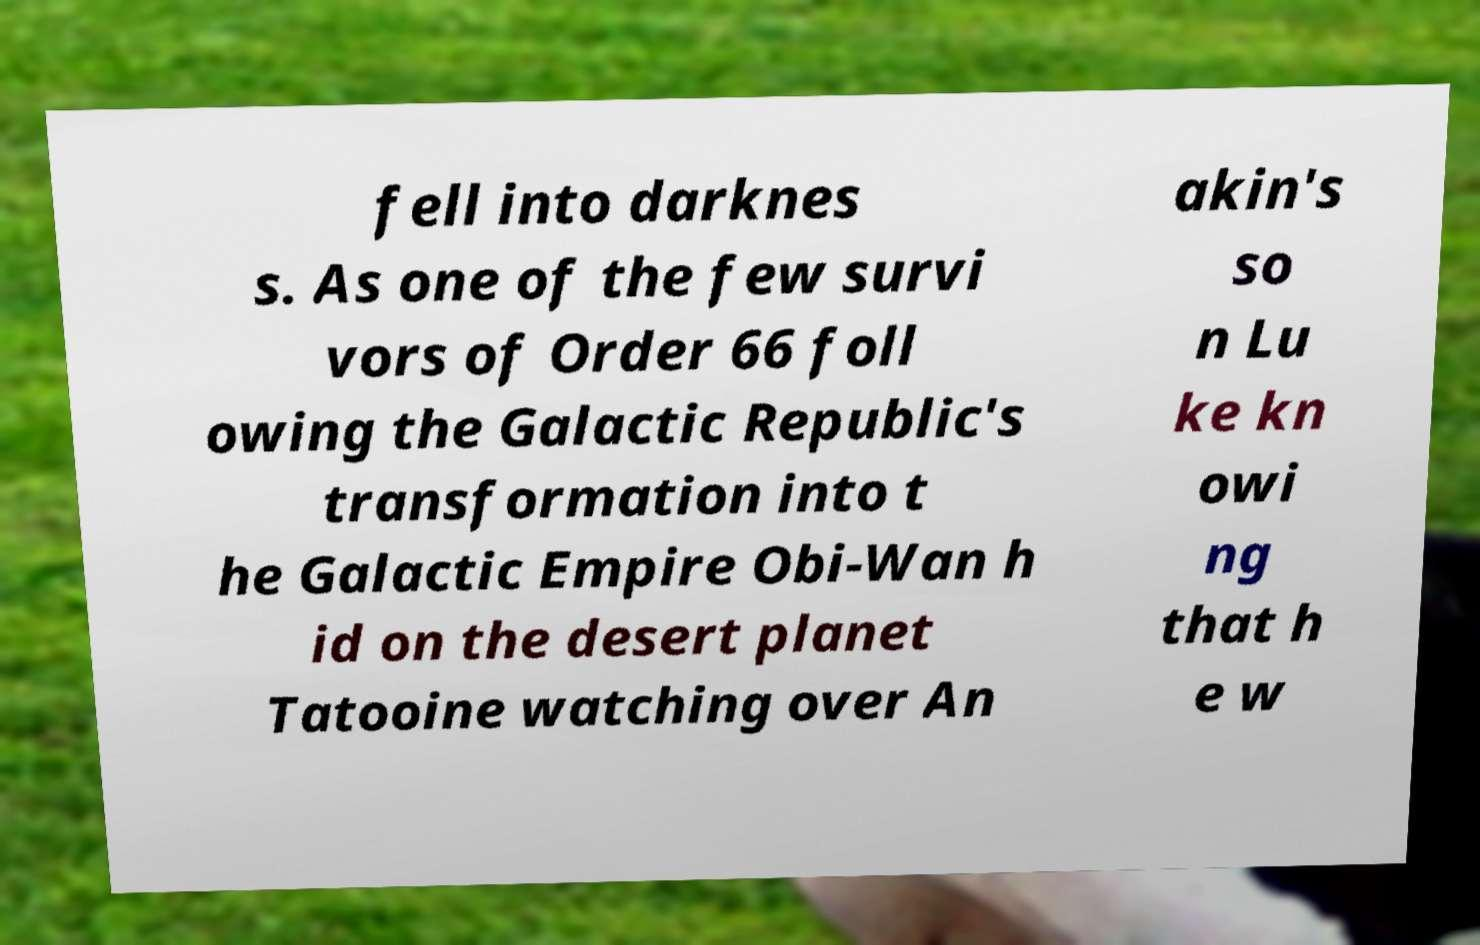Could you assist in decoding the text presented in this image and type it out clearly? fell into darknes s. As one of the few survi vors of Order 66 foll owing the Galactic Republic's transformation into t he Galactic Empire Obi-Wan h id on the desert planet Tatooine watching over An akin's so n Lu ke kn owi ng that h e w 